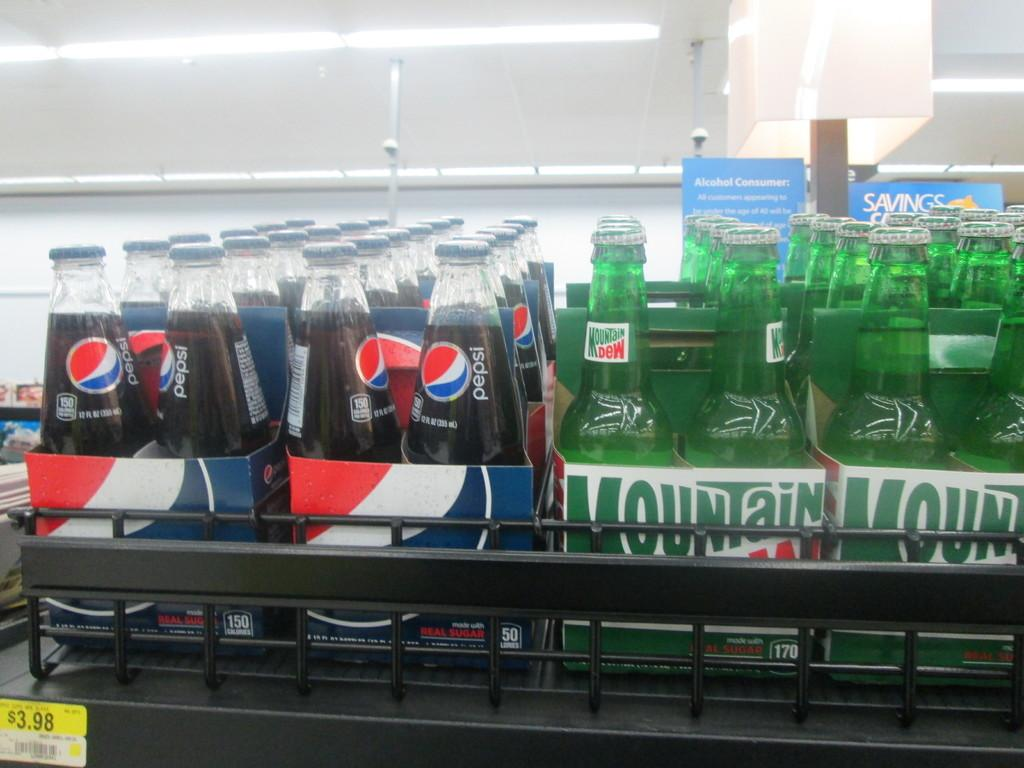<image>
Describe the image concisely. a display of pepsi and mountain dew bottles on a shelf for 3.98 